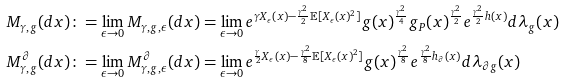<formula> <loc_0><loc_0><loc_500><loc_500>& M _ { \gamma , g } ( d x ) \colon = \lim _ { \epsilon \rightarrow 0 } M _ { \gamma , g , \epsilon } ( d x ) = \lim _ { \epsilon \rightarrow 0 } e ^ { \gamma X _ { \epsilon } ( x ) - \frac { \gamma ^ { 2 } } { 2 } \mathbb { E } [ X _ { \epsilon } ( x ) ^ { 2 } ] } g ( x ) ^ { \frac { \gamma ^ { 2 } } { 4 } } g _ { P } ( x ) ^ { \frac { \gamma ^ { 2 } } { 2 } } e ^ { \frac { \gamma ^ { 2 } } { 2 } h ( x ) } d \lambda _ { g } ( x ) \\ & M ^ { \partial } _ { \gamma , g } ( d x ) \colon = \lim _ { \epsilon \rightarrow 0 } M ^ { \partial } _ { \gamma , g , \epsilon } ( d x ) = \lim _ { \epsilon \rightarrow 0 } e ^ { \frac { \gamma } { 2 } X _ { \epsilon } ( x ) - \frac { \gamma ^ { 2 } } { 8 } \mathbb { E } [ X _ { \epsilon } ( x ) ^ { 2 } ] } g ( x ) ^ { \frac { \gamma ^ { 2 } } { 8 } } e ^ { \frac { \gamma ^ { 2 } } { 8 } h _ { \partial } ( x ) } d \lambda _ { \partial g } ( x )</formula> 